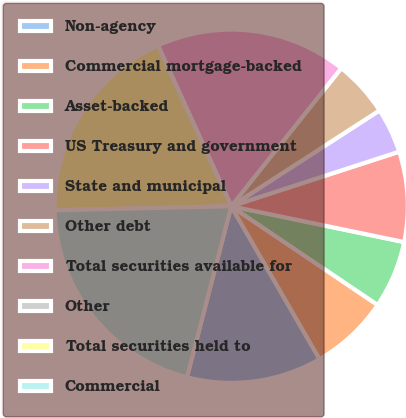Convert chart. <chart><loc_0><loc_0><loc_500><loc_500><pie_chart><fcel>Non-agency<fcel>Commercial mortgage-backed<fcel>Asset-backed<fcel>US Treasury and government<fcel>State and municipal<fcel>Other debt<fcel>Total securities available for<fcel>Other<fcel>Total securities held to<fcel>Commercial<nl><fcel>12.37%<fcel>7.22%<fcel>6.19%<fcel>8.25%<fcel>4.13%<fcel>5.16%<fcel>17.52%<fcel>0.01%<fcel>18.55%<fcel>20.61%<nl></chart> 